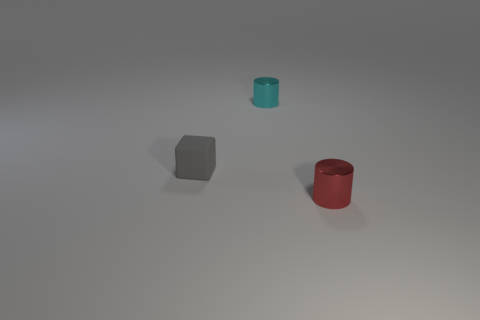Add 2 tiny rubber cubes. How many objects exist? 5 Subtract all blocks. How many objects are left? 2 Add 3 small matte blocks. How many small matte blocks are left? 4 Add 1 big green matte objects. How many big green matte objects exist? 1 Subtract 0 green spheres. How many objects are left? 3 Subtract all tiny metal objects. Subtract all tiny red cylinders. How many objects are left? 0 